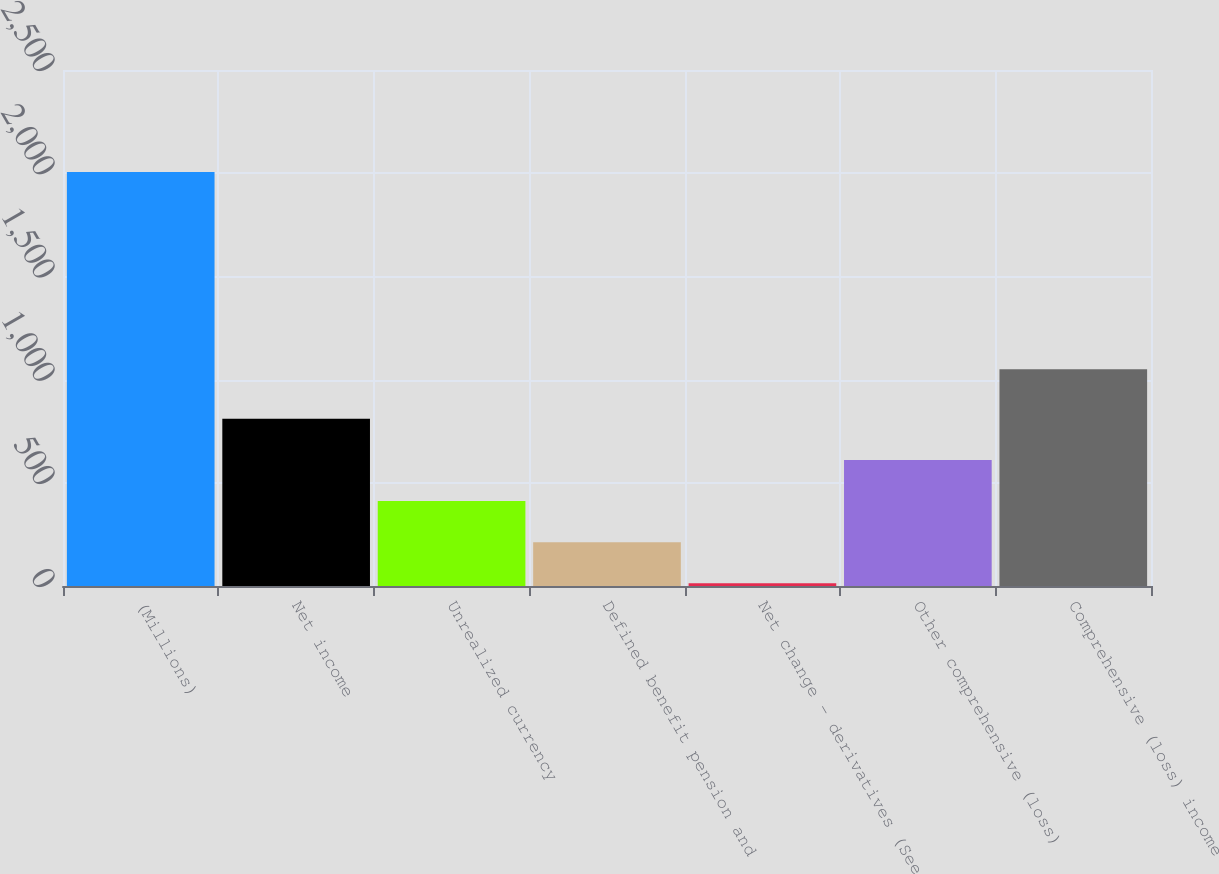Convert chart to OTSL. <chart><loc_0><loc_0><loc_500><loc_500><bar_chart><fcel>(Millions)<fcel>Net income<fcel>Unrealized currency<fcel>Defined benefit pension and<fcel>Net change - derivatives (See<fcel>Other comprehensive (loss)<fcel>Comprehensive (loss) income<nl><fcel>2006<fcel>810.2<fcel>411.6<fcel>212.3<fcel>13<fcel>610.9<fcel>1050<nl></chart> 